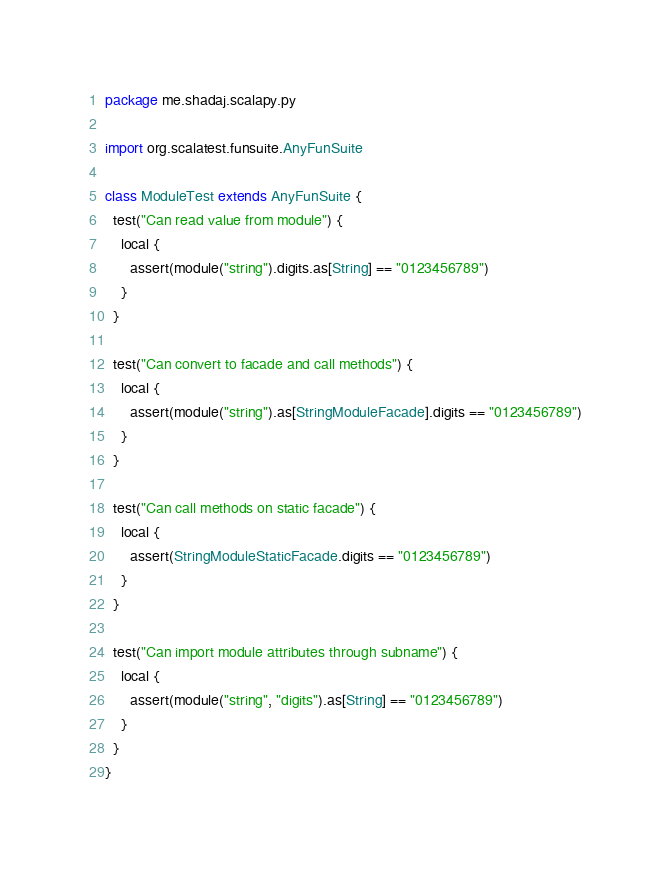Convert code to text. <code><loc_0><loc_0><loc_500><loc_500><_Scala_>package me.shadaj.scalapy.py

import org.scalatest.funsuite.AnyFunSuite

class ModuleTest extends AnyFunSuite {
  test("Can read value from module") {
    local {
      assert(module("string").digits.as[String] == "0123456789")
    }
  }

  test("Can convert to facade and call methods") {
    local {
      assert(module("string").as[StringModuleFacade].digits == "0123456789")
    }
  }

  test("Can call methods on static facade") {
    local {
      assert(StringModuleStaticFacade.digits == "0123456789")
    }
  }

  test("Can import module attributes through subname") {
    local {
      assert(module("string", "digits").as[String] == "0123456789")
    }
  }
}
</code> 